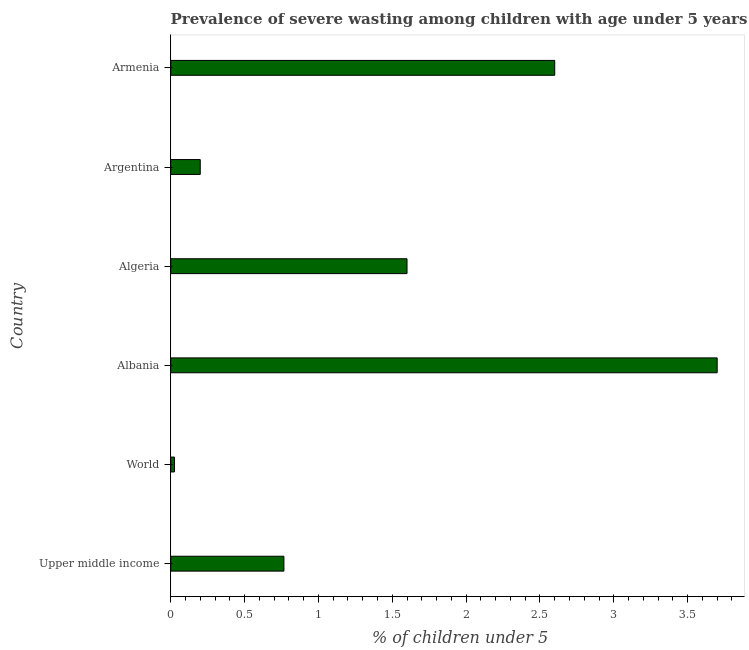Does the graph contain any zero values?
Keep it short and to the point. No. What is the title of the graph?
Give a very brief answer. Prevalence of severe wasting among children with age under 5 years in 2005. What is the label or title of the X-axis?
Your answer should be very brief.  % of children under 5. What is the prevalence of severe wasting in Upper middle income?
Make the answer very short. 0.77. Across all countries, what is the maximum prevalence of severe wasting?
Ensure brevity in your answer.  3.7. Across all countries, what is the minimum prevalence of severe wasting?
Ensure brevity in your answer.  0.03. In which country was the prevalence of severe wasting maximum?
Your response must be concise. Albania. In which country was the prevalence of severe wasting minimum?
Your answer should be very brief. World. What is the sum of the prevalence of severe wasting?
Give a very brief answer. 8.89. What is the difference between the prevalence of severe wasting in Albania and Argentina?
Your answer should be compact. 3.5. What is the average prevalence of severe wasting per country?
Your response must be concise. 1.48. What is the median prevalence of severe wasting?
Your answer should be compact. 1.18. What is the ratio of the prevalence of severe wasting in Albania to that in Armenia?
Your response must be concise. 1.42. Is the prevalence of severe wasting in Argentina less than that in World?
Keep it short and to the point. No. Is the difference between the prevalence of severe wasting in Albania and Algeria greater than the difference between any two countries?
Your answer should be very brief. No. Is the sum of the prevalence of severe wasting in Albania and World greater than the maximum prevalence of severe wasting across all countries?
Offer a very short reply. Yes. What is the difference between the highest and the lowest prevalence of severe wasting?
Keep it short and to the point. 3.67. In how many countries, is the prevalence of severe wasting greater than the average prevalence of severe wasting taken over all countries?
Your answer should be compact. 3. How many bars are there?
Keep it short and to the point. 6. Are all the bars in the graph horizontal?
Keep it short and to the point. Yes. How many countries are there in the graph?
Offer a very short reply. 6. What is the difference between two consecutive major ticks on the X-axis?
Give a very brief answer. 0.5. What is the  % of children under 5 of Upper middle income?
Your answer should be compact. 0.77. What is the  % of children under 5 in World?
Provide a short and direct response. 0.03. What is the  % of children under 5 in Albania?
Give a very brief answer. 3.7. What is the  % of children under 5 in Algeria?
Provide a short and direct response. 1.6. What is the  % of children under 5 in Argentina?
Keep it short and to the point. 0.2. What is the  % of children under 5 of Armenia?
Your response must be concise. 2.6. What is the difference between the  % of children under 5 in Upper middle income and World?
Keep it short and to the point. 0.74. What is the difference between the  % of children under 5 in Upper middle income and Albania?
Your response must be concise. -2.93. What is the difference between the  % of children under 5 in Upper middle income and Algeria?
Your response must be concise. -0.83. What is the difference between the  % of children under 5 in Upper middle income and Argentina?
Offer a terse response. 0.57. What is the difference between the  % of children under 5 in Upper middle income and Armenia?
Offer a terse response. -1.83. What is the difference between the  % of children under 5 in World and Albania?
Your answer should be very brief. -3.67. What is the difference between the  % of children under 5 in World and Algeria?
Offer a very short reply. -1.57. What is the difference between the  % of children under 5 in World and Argentina?
Ensure brevity in your answer.  -0.17. What is the difference between the  % of children under 5 in World and Armenia?
Your answer should be very brief. -2.57. What is the difference between the  % of children under 5 in Albania and Algeria?
Keep it short and to the point. 2.1. What is the difference between the  % of children under 5 in Albania and Argentina?
Your answer should be compact. 3.5. What is the difference between the  % of children under 5 in Albania and Armenia?
Offer a terse response. 1.1. What is the difference between the  % of children under 5 in Algeria and Argentina?
Keep it short and to the point. 1.4. What is the difference between the  % of children under 5 in Algeria and Armenia?
Make the answer very short. -1. What is the difference between the  % of children under 5 in Argentina and Armenia?
Keep it short and to the point. -2.4. What is the ratio of the  % of children under 5 in Upper middle income to that in World?
Offer a very short reply. 30.04. What is the ratio of the  % of children under 5 in Upper middle income to that in Albania?
Give a very brief answer. 0.21. What is the ratio of the  % of children under 5 in Upper middle income to that in Algeria?
Your answer should be very brief. 0.48. What is the ratio of the  % of children under 5 in Upper middle income to that in Argentina?
Make the answer very short. 3.83. What is the ratio of the  % of children under 5 in Upper middle income to that in Armenia?
Keep it short and to the point. 0.29. What is the ratio of the  % of children under 5 in World to that in Albania?
Give a very brief answer. 0.01. What is the ratio of the  % of children under 5 in World to that in Algeria?
Offer a very short reply. 0.02. What is the ratio of the  % of children under 5 in World to that in Argentina?
Your answer should be compact. 0.13. What is the ratio of the  % of children under 5 in Albania to that in Algeria?
Offer a terse response. 2.31. What is the ratio of the  % of children under 5 in Albania to that in Armenia?
Your answer should be very brief. 1.42. What is the ratio of the  % of children under 5 in Algeria to that in Argentina?
Make the answer very short. 8. What is the ratio of the  % of children under 5 in Algeria to that in Armenia?
Provide a succinct answer. 0.61. What is the ratio of the  % of children under 5 in Argentina to that in Armenia?
Ensure brevity in your answer.  0.08. 